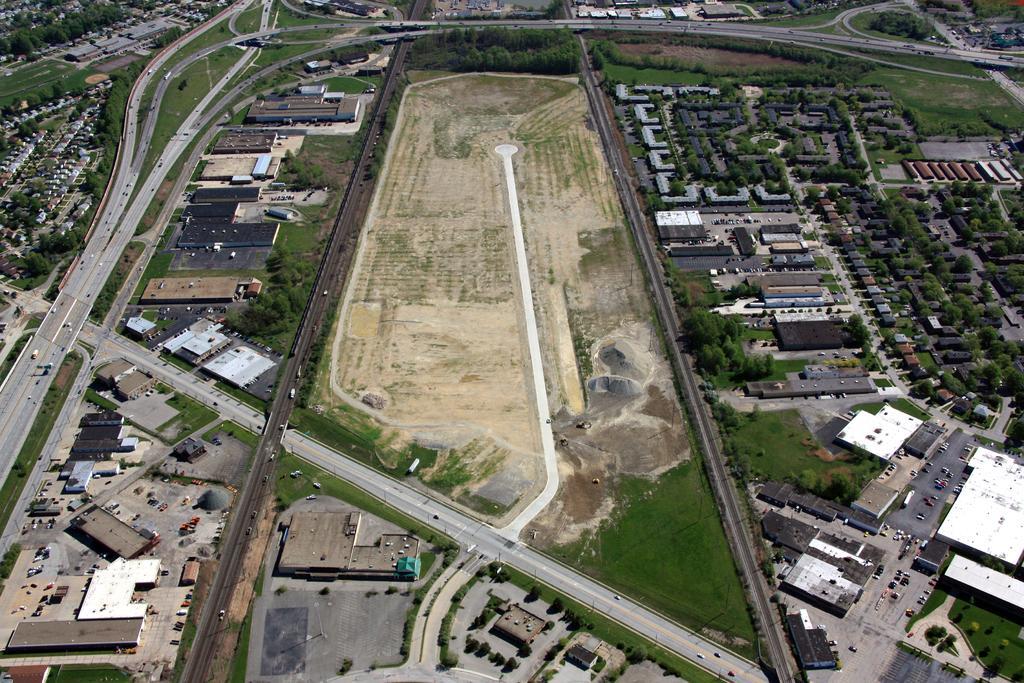Can you describe this image briefly? This image is taken indoors. In this image there is a ground with grass on it and there are many roads. There are many buildings, houses, trees, plants and vehicles on the ground. A few vehicles are moving on the road and a few are parked on the ground. 